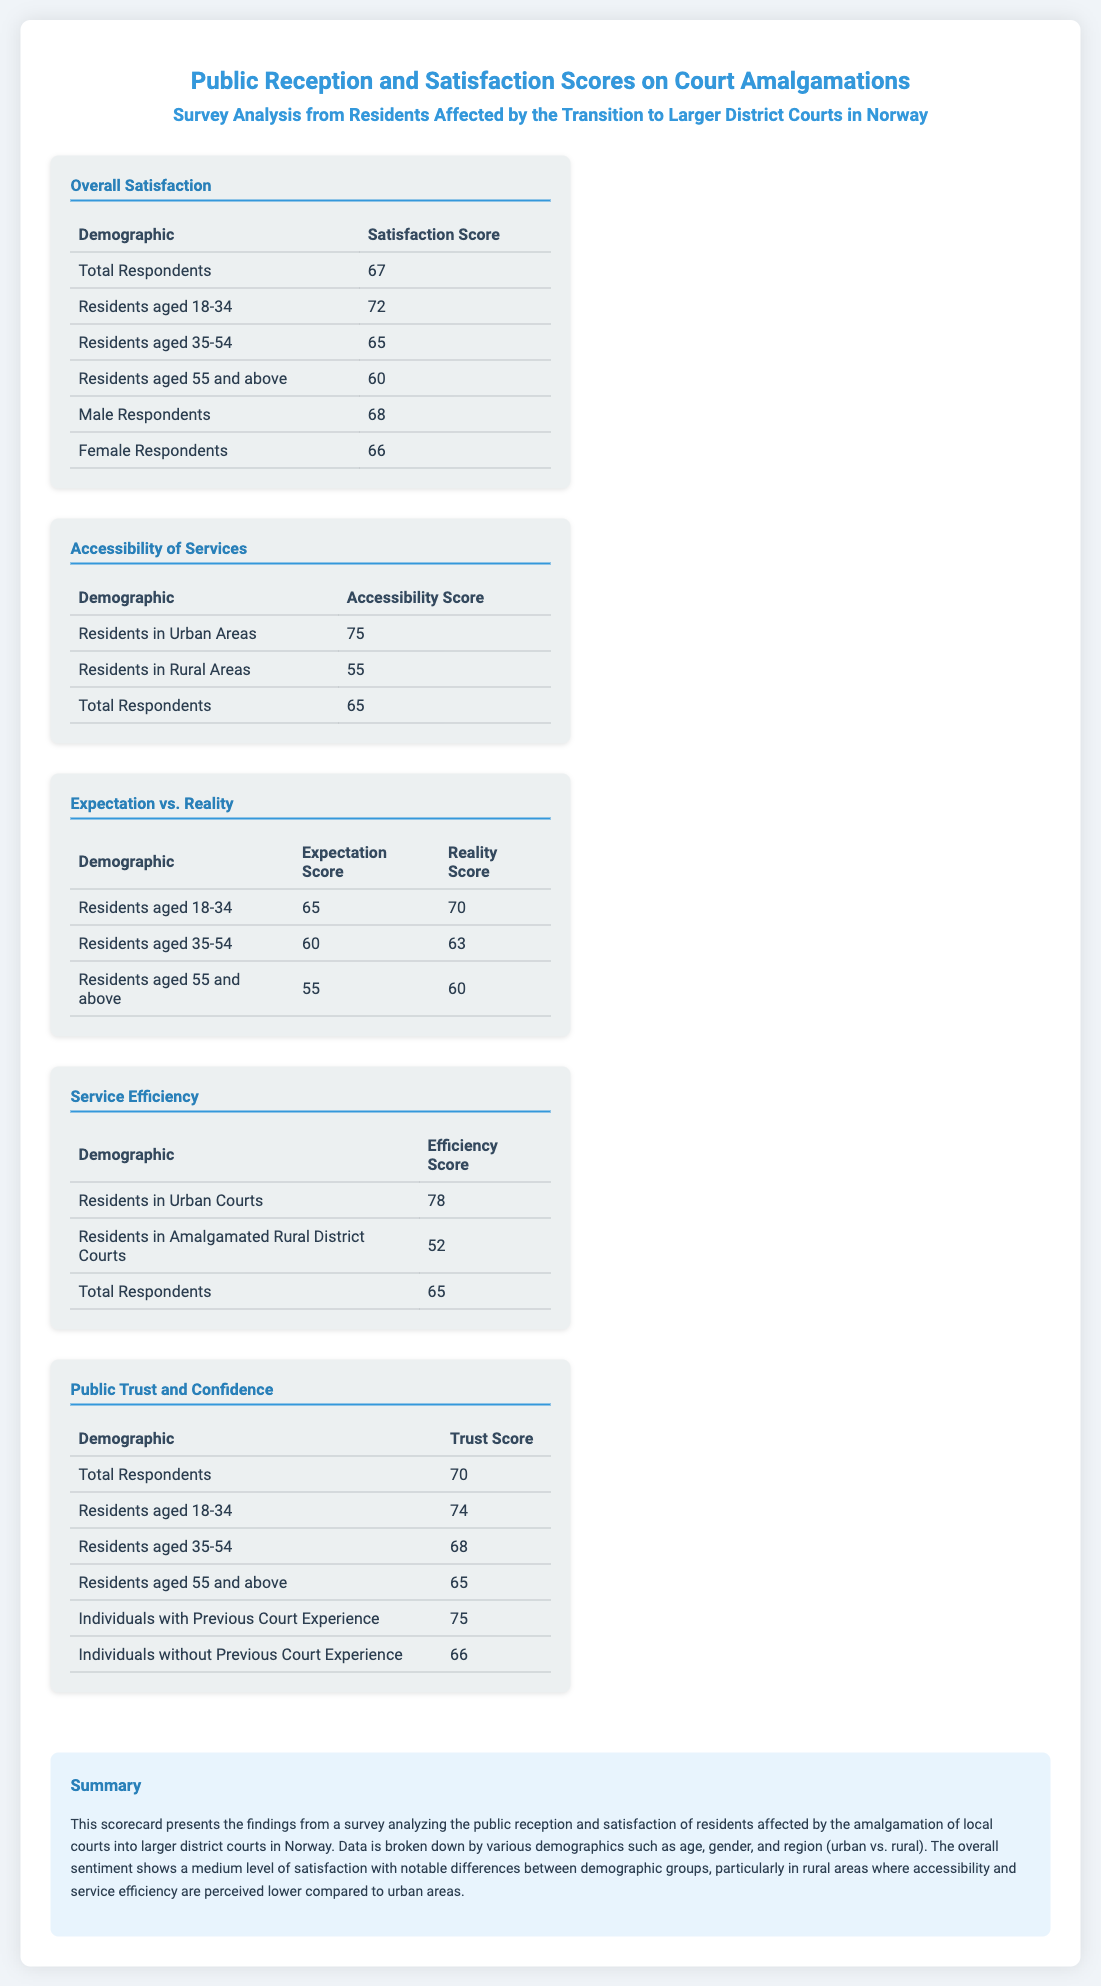What is the overall satisfaction score of residents aged 18-34? The scorecard indicates that residents aged 18-34 have an overall satisfaction score of 72.
Answer: 72 What is the accessibility score for residents in rural areas? According to the scorecard, residents in rural areas have an accessibility score of 55.
Answer: 55 What is the efficiency score for residents in amalgamated rural district courts? The scorecard shows that residents in amalgamated rural district courts have an efficiency score of 52.
Answer: 52 What is the trust score for individuals with previous court experience? The scorecard states that individuals with previous court experience have a trust score of 75.
Answer: 75 How many total respondents participated in the satisfaction survey? The total number of respondents indicated in the scorecard is 67.
Answer: 67 What is the expectation score for residents aged 55 and above? The expectation score for residents aged 55 and above is reported as 55 in the scorecard.
Answer: 55 Which demographic has the highest score for public trust and confidence? The demographic with the highest score for public trust and confidence is individuals with previous court experience, with a score of 75.
Answer: Individuals with Previous Court Experience What is the average accessibility score of urban residents? Urban residents have an accessibility score of 75, which is mentioned in the scorecard.
Answer: 75 Which demographic group scored lowest in service efficiency? The demographic group that scored lowest in service efficiency is residents in amalgamated rural district courts, with a score of 52.
Answer: Residents in Amalgamated Rural District Courts 